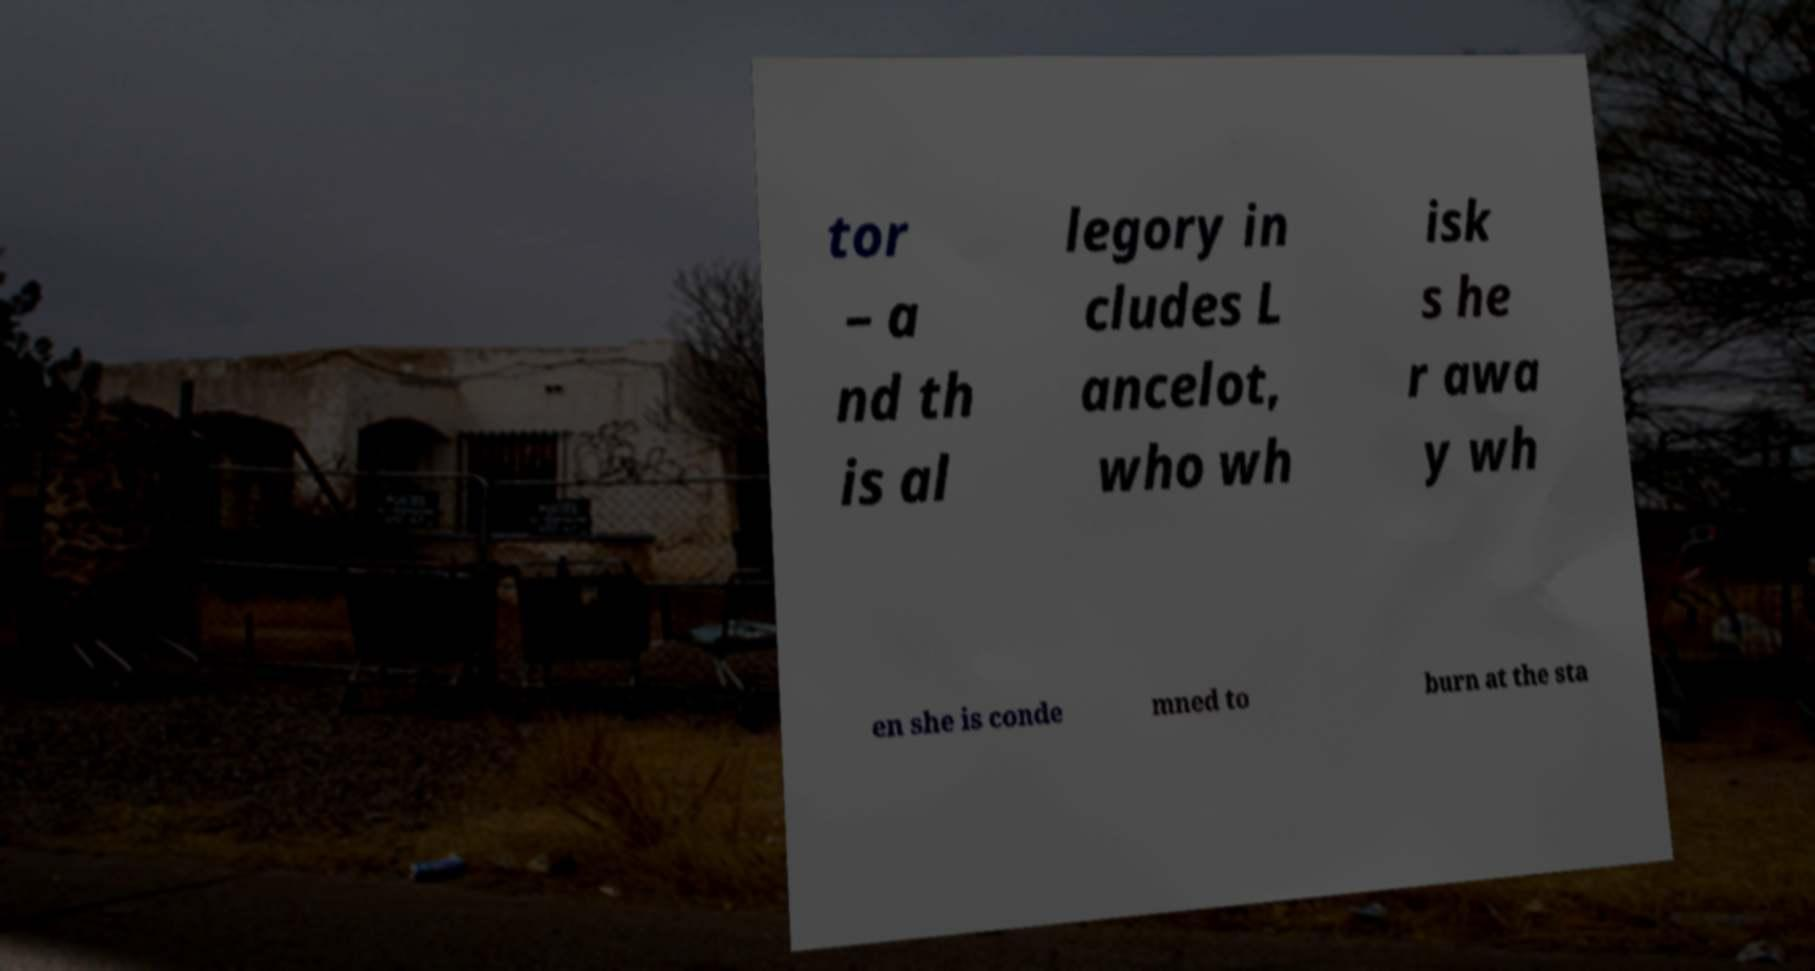Could you assist in decoding the text presented in this image and type it out clearly? tor – a nd th is al legory in cludes L ancelot, who wh isk s he r awa y wh en she is conde mned to burn at the sta 